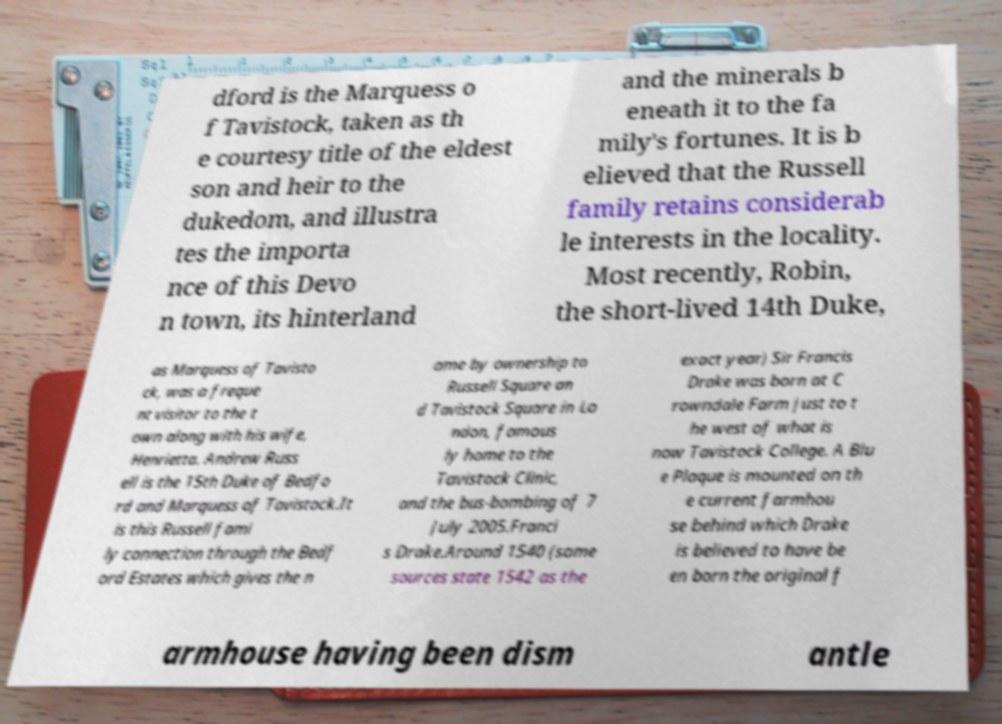Can you accurately transcribe the text from the provided image for me? dford is the Marquess o f Tavistock, taken as th e courtesy title of the eldest son and heir to the dukedom, and illustra tes the importa nce of this Devo n town, its hinterland and the minerals b eneath it to the fa mily's fortunes. It is b elieved that the Russell family retains considerab le interests in the locality. Most recently, Robin, the short-lived 14th Duke, as Marquess of Tavisto ck, was a freque nt visitor to the t own along with his wife, Henrietta. Andrew Russ ell is the 15th Duke of Bedfo rd and Marquess of Tavistock.It is this Russell fami ly connection through the Bedf ord Estates which gives the n ame by ownership to Russell Square an d Tavistock Square in Lo ndon, famous ly home to the Tavistock Clinic, and the bus-bombing of 7 July 2005.Franci s Drake.Around 1540 (some sources state 1542 as the exact year) Sir Francis Drake was born at C rowndale Farm just to t he west of what is now Tavistock College. A Blu e Plaque is mounted on th e current farmhou se behind which Drake is believed to have be en born the original f armhouse having been dism antle 